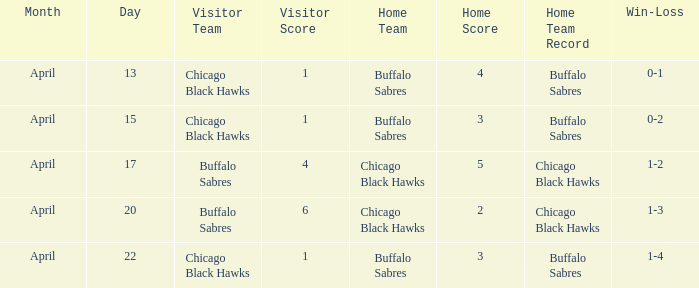Name the Visitor that has a Home of chicago black hawks on april 20? Buffalo Sabres. 